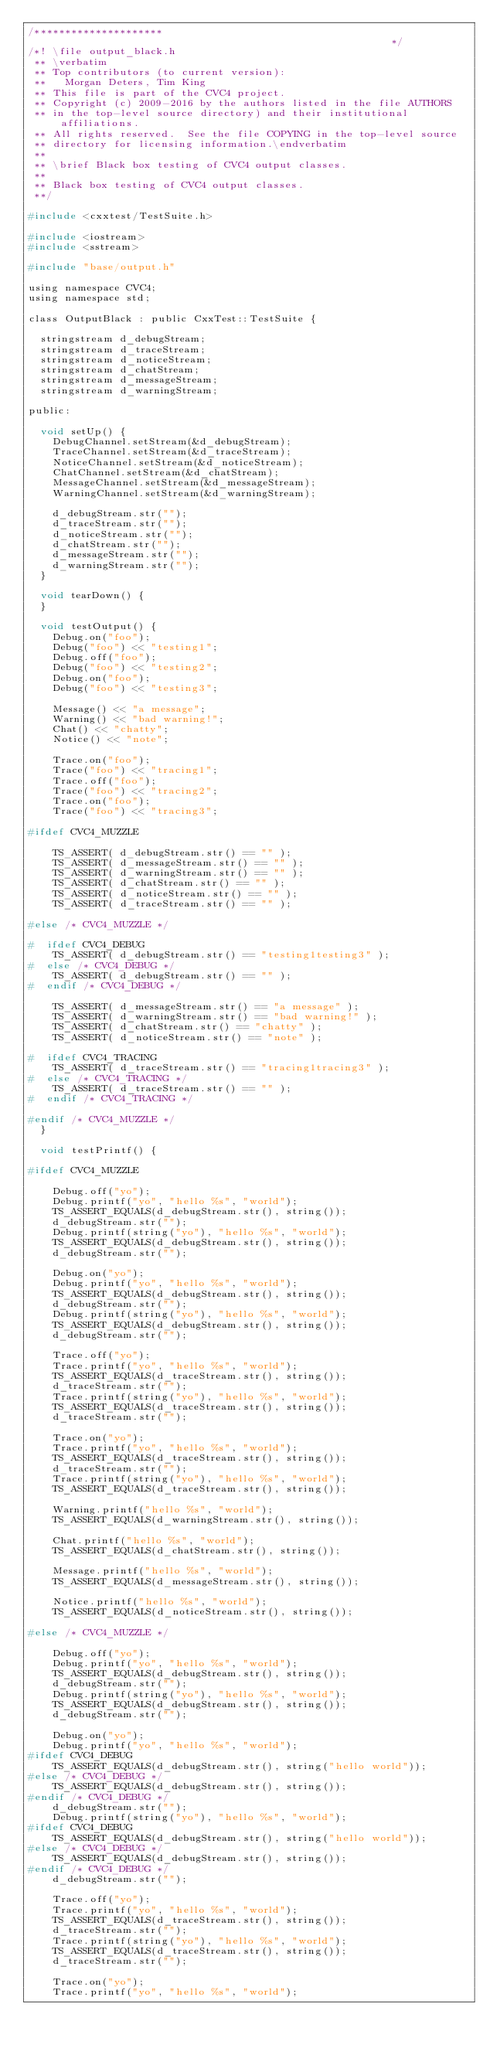Convert code to text. <code><loc_0><loc_0><loc_500><loc_500><_C_>/*********************                                                        */
/*! \file output_black.h
 ** \verbatim
 ** Top contributors (to current version):
 **   Morgan Deters, Tim King
 ** This file is part of the CVC4 project.
 ** Copyright (c) 2009-2016 by the authors listed in the file AUTHORS
 ** in the top-level source directory) and their institutional affiliations.
 ** All rights reserved.  See the file COPYING in the top-level source
 ** directory for licensing information.\endverbatim
 **
 ** \brief Black box testing of CVC4 output classes.
 **
 ** Black box testing of CVC4 output classes.
 **/

#include <cxxtest/TestSuite.h>

#include <iostream>
#include <sstream>

#include "base/output.h"

using namespace CVC4;
using namespace std;

class OutputBlack : public CxxTest::TestSuite {

  stringstream d_debugStream;
  stringstream d_traceStream;
  stringstream d_noticeStream;
  stringstream d_chatStream;
  stringstream d_messageStream;
  stringstream d_warningStream;

public:

  void setUp() {
    DebugChannel.setStream(&d_debugStream);
    TraceChannel.setStream(&d_traceStream);
    NoticeChannel.setStream(&d_noticeStream);
    ChatChannel.setStream(&d_chatStream);
    MessageChannel.setStream(&d_messageStream);
    WarningChannel.setStream(&d_warningStream);

    d_debugStream.str("");
    d_traceStream.str("");
    d_noticeStream.str("");
    d_chatStream.str("");
    d_messageStream.str("");
    d_warningStream.str("");
  }

  void tearDown() {
  }

  void testOutput() {
    Debug.on("foo");
    Debug("foo") << "testing1";
    Debug.off("foo");
    Debug("foo") << "testing2";
    Debug.on("foo");
    Debug("foo") << "testing3";

    Message() << "a message";
    Warning() << "bad warning!";
    Chat() << "chatty";
    Notice() << "note";

    Trace.on("foo");
    Trace("foo") << "tracing1";
    Trace.off("foo");
    Trace("foo") << "tracing2";
    Trace.on("foo");
    Trace("foo") << "tracing3";

#ifdef CVC4_MUZZLE

    TS_ASSERT( d_debugStream.str() == "" );
    TS_ASSERT( d_messageStream.str() == "" );
    TS_ASSERT( d_warningStream.str() == "" );
    TS_ASSERT( d_chatStream.str() == "" );
    TS_ASSERT( d_noticeStream.str() == "" );
    TS_ASSERT( d_traceStream.str() == "" );

#else /* CVC4_MUZZLE */

#  ifdef CVC4_DEBUG
    TS_ASSERT( d_debugStream.str() == "testing1testing3" );
#  else /* CVC4_DEBUG */
    TS_ASSERT( d_debugStream.str() == "" );
#  endif /* CVC4_DEBUG */

    TS_ASSERT( d_messageStream.str() == "a message" );
    TS_ASSERT( d_warningStream.str() == "bad warning!" );
    TS_ASSERT( d_chatStream.str() == "chatty" );
    TS_ASSERT( d_noticeStream.str() == "note" );

#  ifdef CVC4_TRACING
    TS_ASSERT( d_traceStream.str() == "tracing1tracing3" );
#  else /* CVC4_TRACING */
    TS_ASSERT( d_traceStream.str() == "" );
#  endif /* CVC4_TRACING */

#endif /* CVC4_MUZZLE */
  }

  void testPrintf() {

#ifdef CVC4_MUZZLE

    Debug.off("yo");
    Debug.printf("yo", "hello %s", "world");
    TS_ASSERT_EQUALS(d_debugStream.str(), string());
    d_debugStream.str("");
    Debug.printf(string("yo"), "hello %s", "world");
    TS_ASSERT_EQUALS(d_debugStream.str(), string());
    d_debugStream.str("");

    Debug.on("yo");
    Debug.printf("yo", "hello %s", "world");
    TS_ASSERT_EQUALS(d_debugStream.str(), string());
    d_debugStream.str("");
    Debug.printf(string("yo"), "hello %s", "world");
    TS_ASSERT_EQUALS(d_debugStream.str(), string());
    d_debugStream.str("");

    Trace.off("yo");
    Trace.printf("yo", "hello %s", "world");
    TS_ASSERT_EQUALS(d_traceStream.str(), string());
    d_traceStream.str("");
    Trace.printf(string("yo"), "hello %s", "world");
    TS_ASSERT_EQUALS(d_traceStream.str(), string());
    d_traceStream.str("");

    Trace.on("yo");
    Trace.printf("yo", "hello %s", "world");
    TS_ASSERT_EQUALS(d_traceStream.str(), string());
    d_traceStream.str("");
    Trace.printf(string("yo"), "hello %s", "world");
    TS_ASSERT_EQUALS(d_traceStream.str(), string());

    Warning.printf("hello %s", "world");
    TS_ASSERT_EQUALS(d_warningStream.str(), string());

    Chat.printf("hello %s", "world");
    TS_ASSERT_EQUALS(d_chatStream.str(), string());

    Message.printf("hello %s", "world");
    TS_ASSERT_EQUALS(d_messageStream.str(), string());

    Notice.printf("hello %s", "world");
    TS_ASSERT_EQUALS(d_noticeStream.str(), string());

#else /* CVC4_MUZZLE */

    Debug.off("yo");
    Debug.printf("yo", "hello %s", "world");
    TS_ASSERT_EQUALS(d_debugStream.str(), string());
    d_debugStream.str("");
    Debug.printf(string("yo"), "hello %s", "world");
    TS_ASSERT_EQUALS(d_debugStream.str(), string());
    d_debugStream.str("");

    Debug.on("yo");
    Debug.printf("yo", "hello %s", "world");
#ifdef CVC4_DEBUG
    TS_ASSERT_EQUALS(d_debugStream.str(), string("hello world"));
#else /* CVC4_DEBUG */
    TS_ASSERT_EQUALS(d_debugStream.str(), string());
#endif /* CVC4_DEBUG */
    d_debugStream.str("");
    Debug.printf(string("yo"), "hello %s", "world");
#ifdef CVC4_DEBUG
    TS_ASSERT_EQUALS(d_debugStream.str(), string("hello world"));
#else /* CVC4_DEBUG */
    TS_ASSERT_EQUALS(d_debugStream.str(), string());
#endif /* CVC4_DEBUG */
    d_debugStream.str("");

    Trace.off("yo");
    Trace.printf("yo", "hello %s", "world");
    TS_ASSERT_EQUALS(d_traceStream.str(), string());
    d_traceStream.str("");
    Trace.printf(string("yo"), "hello %s", "world");
    TS_ASSERT_EQUALS(d_traceStream.str(), string());
    d_traceStream.str("");

    Trace.on("yo");
    Trace.printf("yo", "hello %s", "world");</code> 